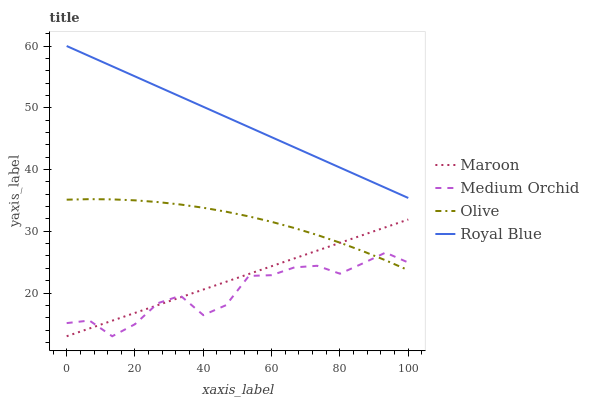Does Medium Orchid have the minimum area under the curve?
Answer yes or no. Yes. Does Royal Blue have the maximum area under the curve?
Answer yes or no. Yes. Does Royal Blue have the minimum area under the curve?
Answer yes or no. No. Does Medium Orchid have the maximum area under the curve?
Answer yes or no. No. Is Maroon the smoothest?
Answer yes or no. Yes. Is Medium Orchid the roughest?
Answer yes or no. Yes. Is Royal Blue the smoothest?
Answer yes or no. No. Is Royal Blue the roughest?
Answer yes or no. No. Does Royal Blue have the lowest value?
Answer yes or no. No. Does Royal Blue have the highest value?
Answer yes or no. Yes. Does Medium Orchid have the highest value?
Answer yes or no. No. Is Olive less than Royal Blue?
Answer yes or no. Yes. Is Royal Blue greater than Olive?
Answer yes or no. Yes. Does Medium Orchid intersect Olive?
Answer yes or no. Yes. Is Medium Orchid less than Olive?
Answer yes or no. No. Is Medium Orchid greater than Olive?
Answer yes or no. No. Does Olive intersect Royal Blue?
Answer yes or no. No. 